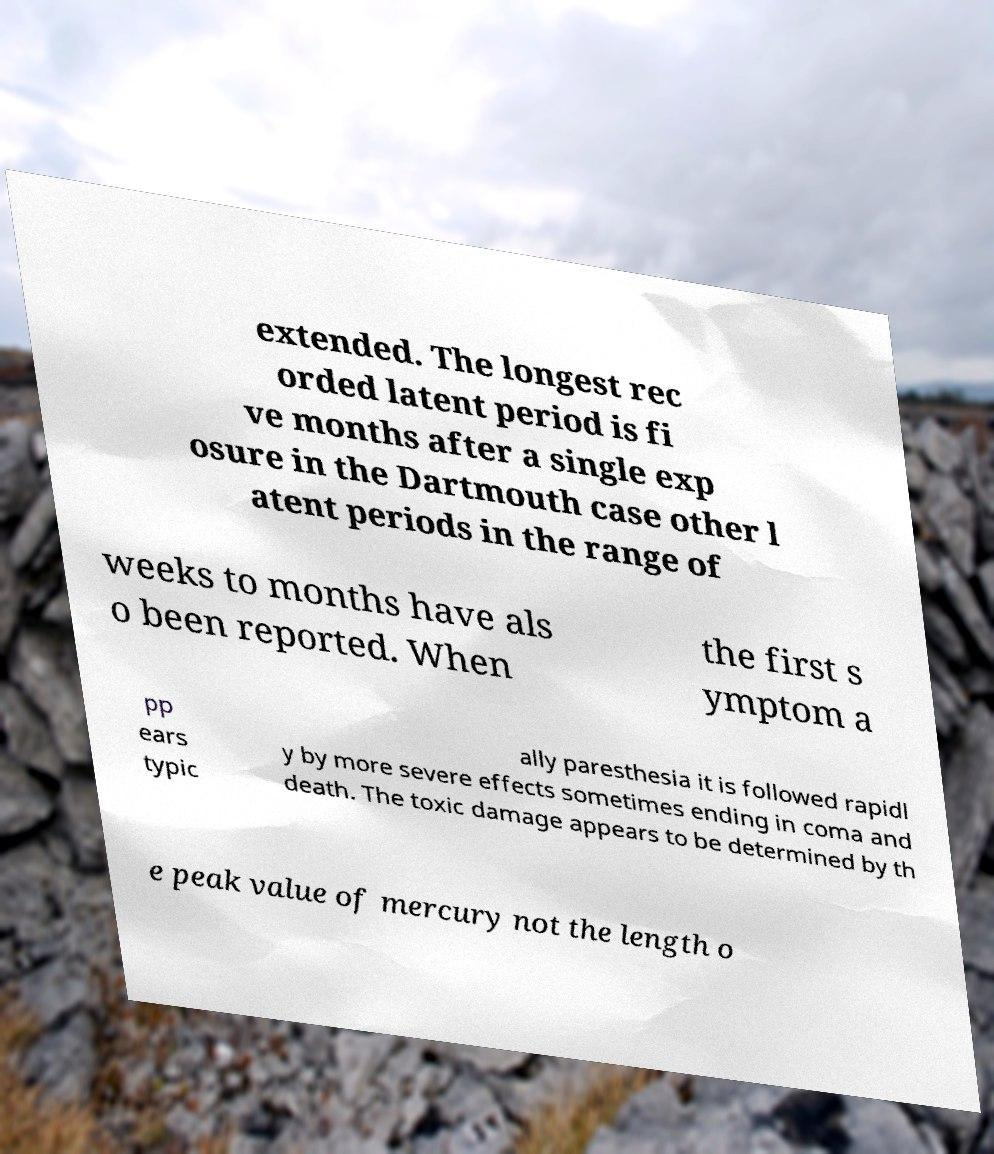What messages or text are displayed in this image? I need them in a readable, typed format. extended. The longest rec orded latent period is fi ve months after a single exp osure in the Dartmouth case other l atent periods in the range of weeks to months have als o been reported. When the first s ymptom a pp ears typic ally paresthesia it is followed rapidl y by more severe effects sometimes ending in coma and death. The toxic damage appears to be determined by th e peak value of mercury not the length o 